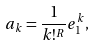<formula> <loc_0><loc_0><loc_500><loc_500>a _ { k } = \frac { 1 } { k ! ^ { R } } e _ { 1 } ^ { k } ,</formula> 